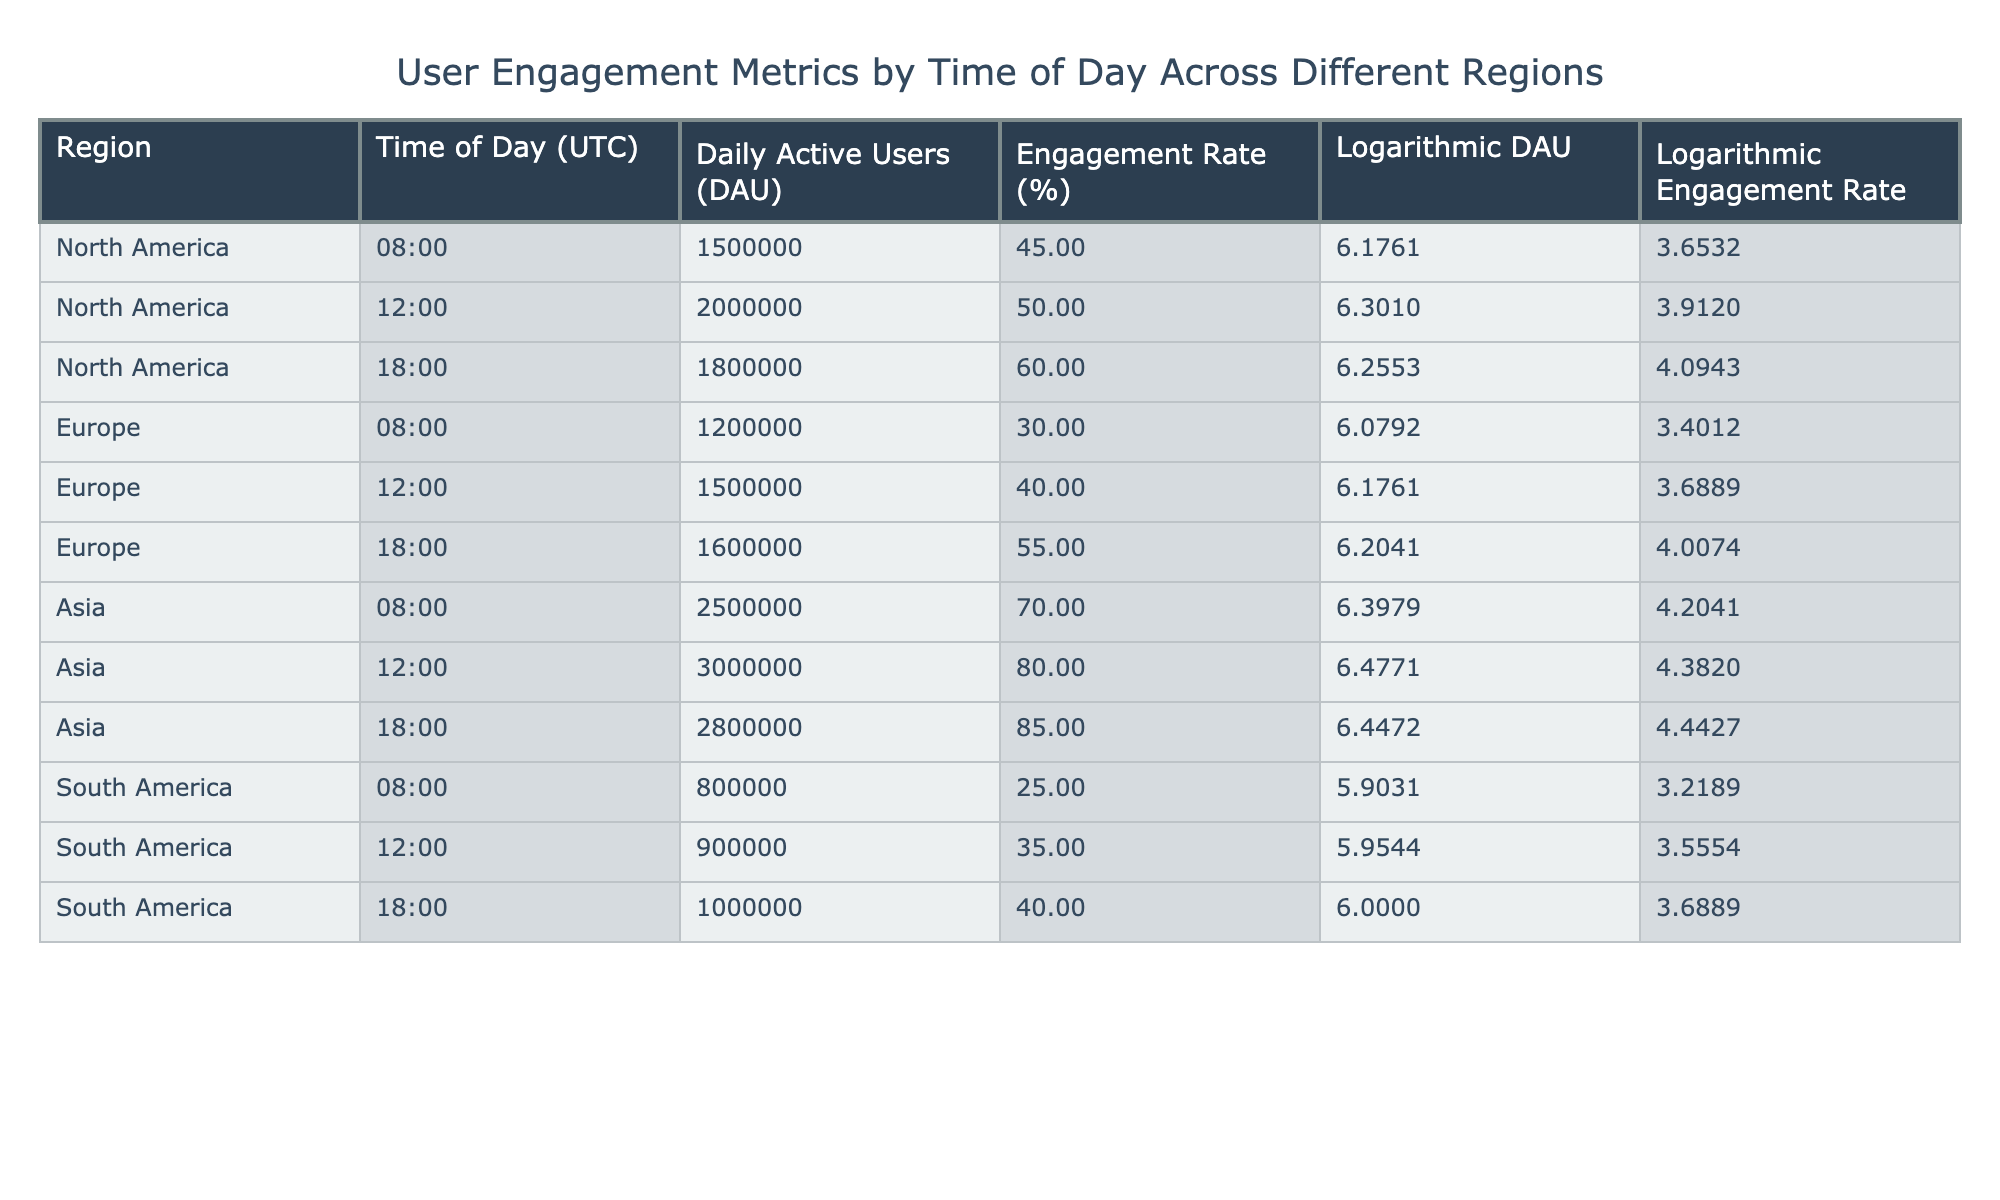What is the engagement rate for users in North America at 18:00? The table lists the engagement rate for North America at 18:00 as 60%.
Answer: 60% What is the logarithmic DAU for users in South America at 12:00? The logarithmic DAU for South America at 12:00 is shown as 5.9544 in the table.
Answer: 5.9544 Which region has the highest engagement rate during the 12:00 time slot? Evaluating the engagement rates at 12:00, Asia has the highest at 80%, compared to 50% in North America, 40% in Europe, and 35% in South America.
Answer: Asia What is the difference in Daily Active Users between Asia at 12:00 and South America at 12:00? At 12:00, Asia has 3,000,000 DAU and South America has 900,000 DAU. The difference is 3,000,000 - 900,000 = 2,100,000.
Answer: 2,100,000 Are there more Daily Active Users in Europe at 18:00 compared to North America at 08:00? Yes, the data shows Europe at 18:00 has 1,600,000 DAU while North America at 08:00 has 1,500,000 DAU, which confirms that Europe has more.
Answer: Yes What is the average engagement rate across all regions at 08:00? The engagement rates at 08:00 are 45% (North America), 30% (Europe), 70% (Asia), and 25% (South America). The average is calculated as (45 + 30 + 70 + 25) / 4 = 42.5%.
Answer: 42.5% At which time of day does Asia exhibit the highest logarithmic engagement rate? Evaluating the logarithmic engagement rates, Asia shows its highest at 12:00 with a value of 4.3820, while the rates at 08:00 and 18:00 are lower.
Answer: 12:00 How many regions have an engagement rate of 55% or higher at 18:00? At 18:00, Asia (85%) and Europe (55%) meet this criterion, thus there are two regions.
Answer: 2 Which region has the least daily active users during the 08:00 time slot? Comparing the DAU at 08:00, South America has the least at 800,000, while North America, Europe, and Asia have higher values.
Answer: South America 